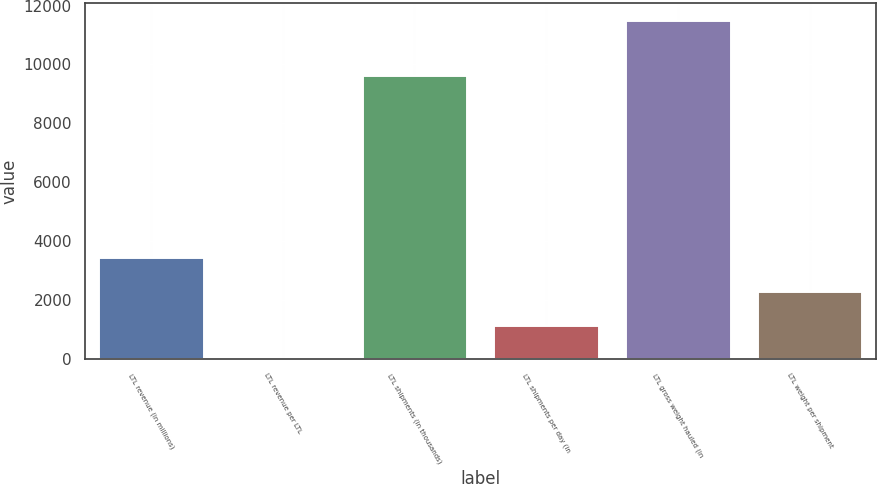Convert chart. <chart><loc_0><loc_0><loc_500><loc_500><bar_chart><fcel>LTL revenue (in millions)<fcel>LTL revenue per LTL<fcel>LTL shipments (in thousands)<fcel>LTL shipments per day (in<fcel>LTL gross weight hauled (in<fcel>LTL weight per shipment<nl><fcel>3460.56<fcel>15.93<fcel>9638<fcel>1164.14<fcel>11498<fcel>2312.35<nl></chart> 